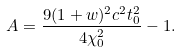<formula> <loc_0><loc_0><loc_500><loc_500>A = \frac { 9 ( 1 + w ) ^ { 2 } c ^ { 2 } t _ { 0 } ^ { 2 } } { 4 \chi _ { 0 } ^ { 2 } } - 1 .</formula> 